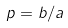Convert formula to latex. <formula><loc_0><loc_0><loc_500><loc_500>p = b / a</formula> 